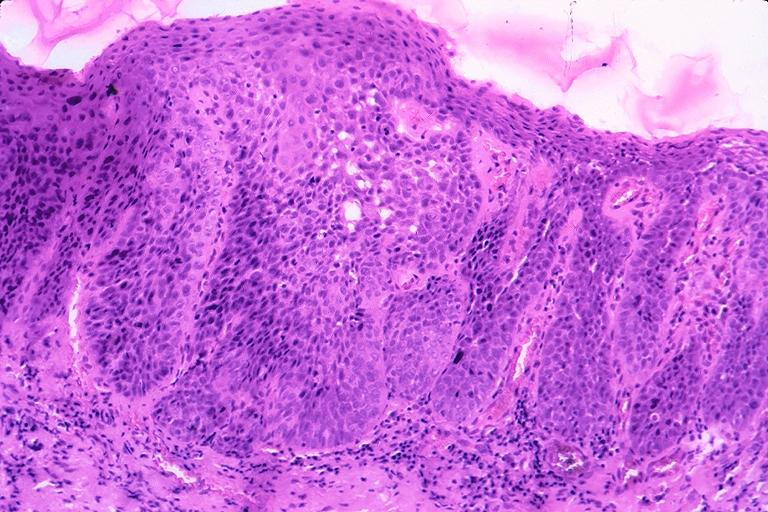what is present?
Answer the question using a single word or phrase. Oral 